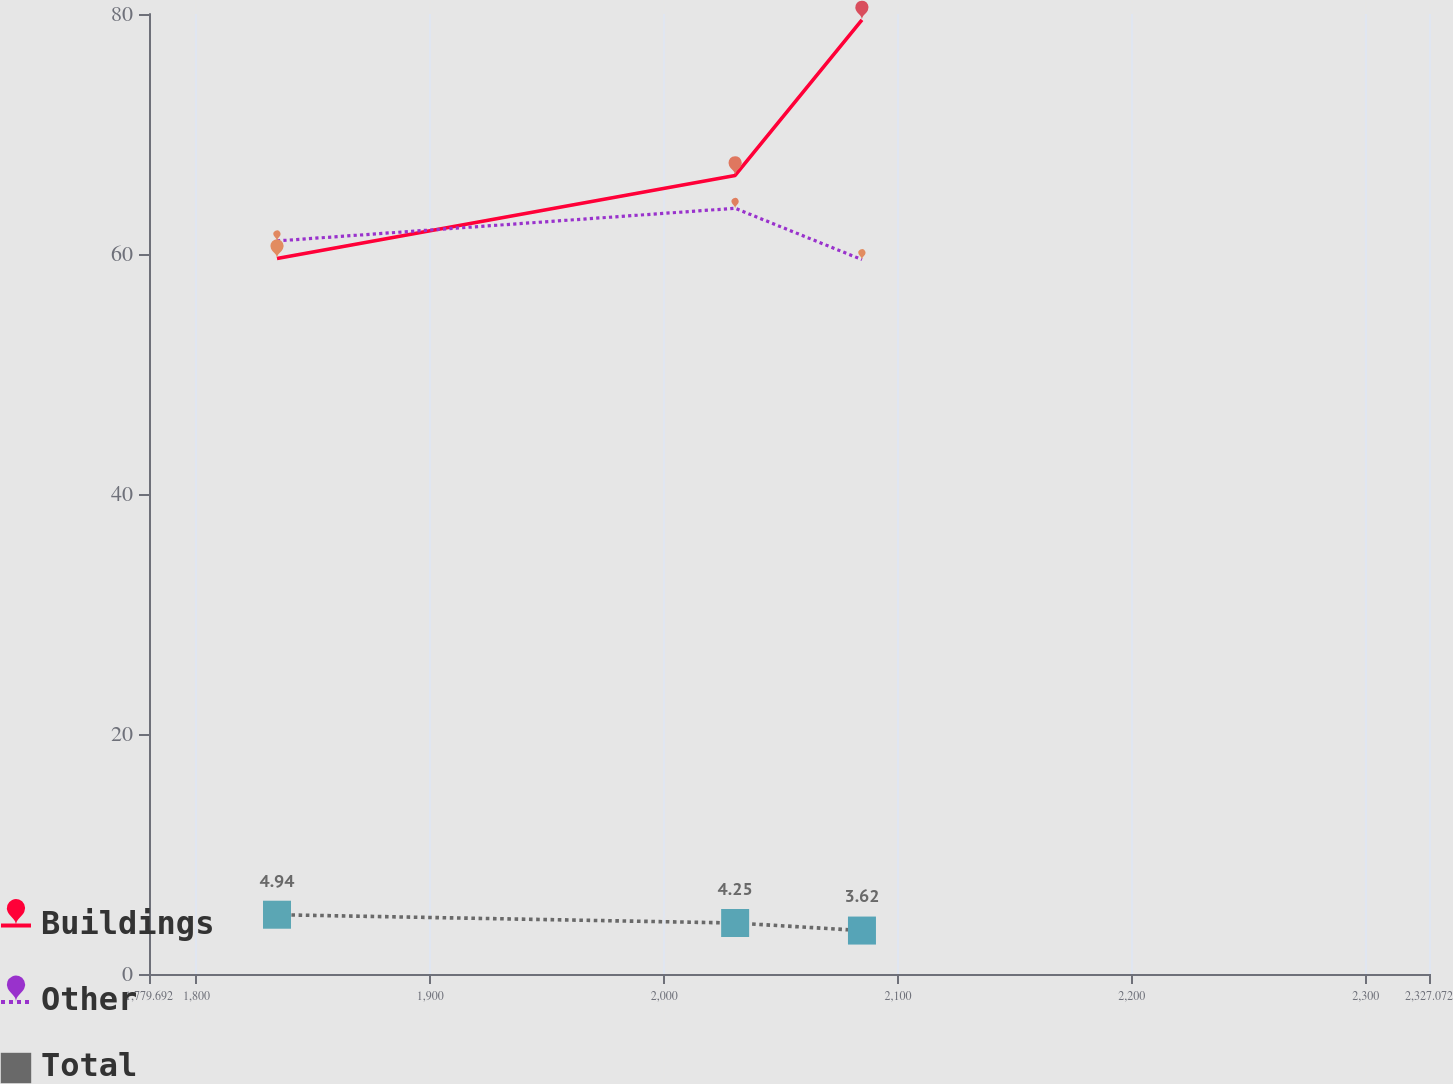Convert chart to OTSL. <chart><loc_0><loc_0><loc_500><loc_500><line_chart><ecel><fcel>Buildings<fcel>Other<fcel>Total<nl><fcel>1834.43<fcel>59.63<fcel>61.09<fcel>4.94<nl><fcel>2030.35<fcel>66.55<fcel>63.81<fcel>4.25<nl><fcel>2084.58<fcel>79.51<fcel>59.53<fcel>3.62<nl><fcel>2330.81<fcel>77.7<fcel>75.09<fcel>3.96<nl><fcel>2381.81<fcel>69.57<fcel>69.15<fcel>2.08<nl></chart> 